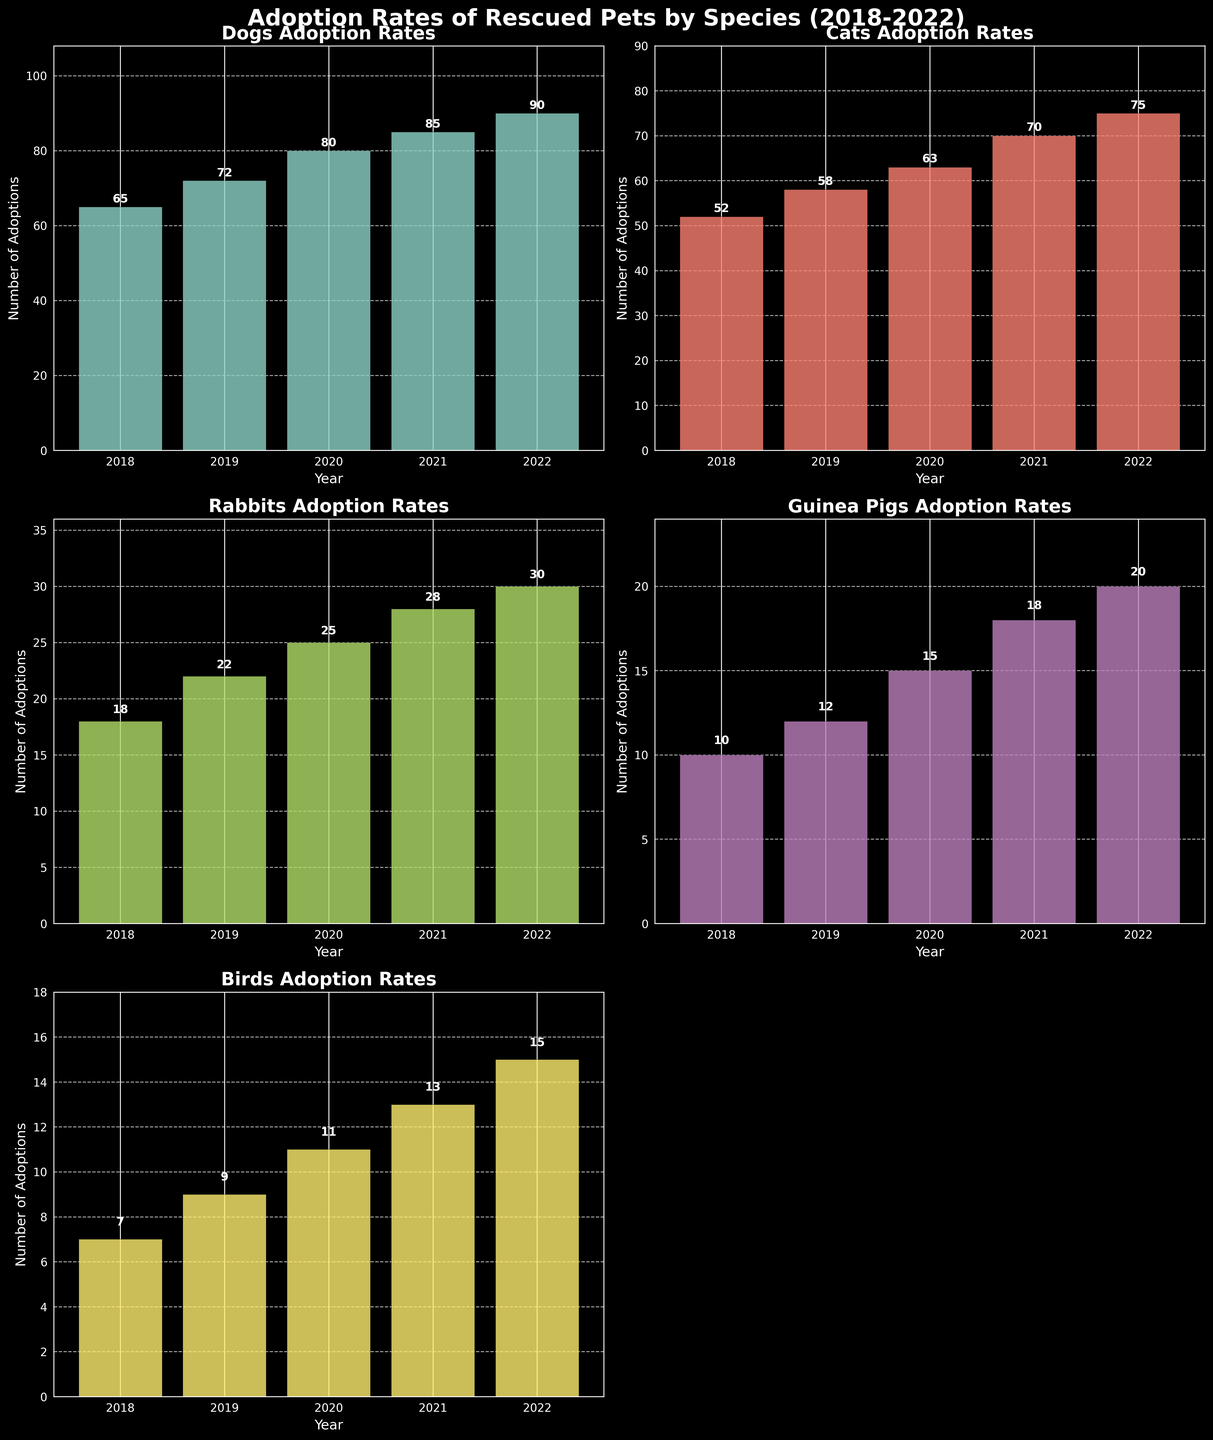What is the title of the figure? The main title is at the top of the figure and reads 'Adoption Rates of Rescued Pets by Species (2018-2022)'.
Answer: Adoption Rates of Rescued Pets by Species (2018-2022) Which species had the highest number of adoptions in 2022? Look at each subplot for the year 2022 and identify the highest bar. The Dogs subplot shows that 90 dogs were adopted in 2022, which is the highest.
Answer: Dogs What is the overall trend in cat adoptions from 2018 to 2022? Check the 'Cats Adoption Rates' subplot and observe the bars from 2018 to 2022. The number of adoptions increases each year.
Answer: Increasing In which year did rabbit adoptions see the biggest increase compared to the previous year? Examine the 'Rabbits Adoption Rates' subplot and compare the height difference between consecutive years. The biggest increase is between 2019 (22) and 2020 (25), which is an increase of 3.
Answer: 2020 How do guinea pig adoptions in 2020 compare to bird adoptions in 2021? Refer to the 'Guinea Pigs Adoption Rates' and 'Birds Adoption Rates' subplots. Guinea Pig adoptions in 2020 were 15, and Bird adoptions in 2021 were 13.
Answer: 15 vs. 13 What is the average number of dog adoptions per year over the past 5 years? Sum the dog adoptions for each year from 2018 to 2022 (65 + 72 + 80 + 85 + 90) and divide by 5. (65 + 72 + 80 + 85 + 90) / 5 = 78.4
Answer: 78.4 Did any species have the same number of adoptions for any two consecutive years? Check each subplot for species and compare bars for each pair of consecutive years. No species has the same number of adoptions in any two consecutive years.
Answer: No Which species had the steadiest increase in adoptions each year? Analyze the incremental increases in each species' adoption rates for each year. Cats and Dogs both show a steady increase, but Dogs have a slightly more consistent increase over the years.
Answer: Dogs 